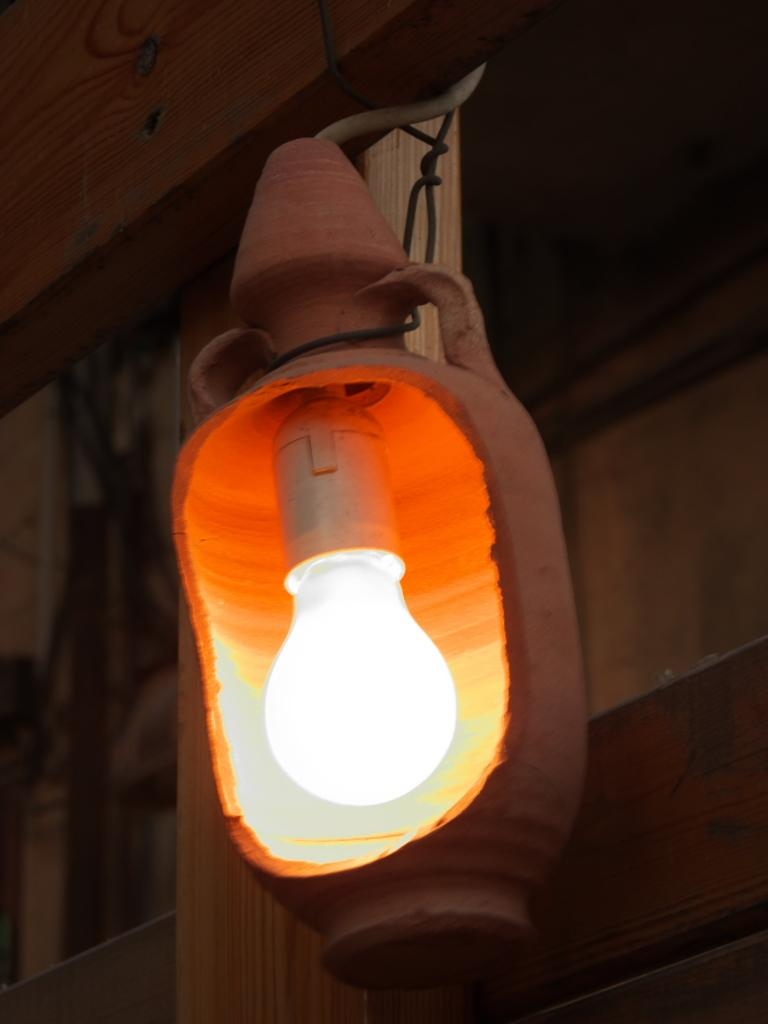What is the main subject of the image? The main subject of the image is a blown bulb. Can you describe the condition of the bulb? The bulb is blown, which means it is not functioning or providing light. What type of cherries are being cooked on the stove in the image? There is no stove or cherries present in the image; it only features a blown bulb. 